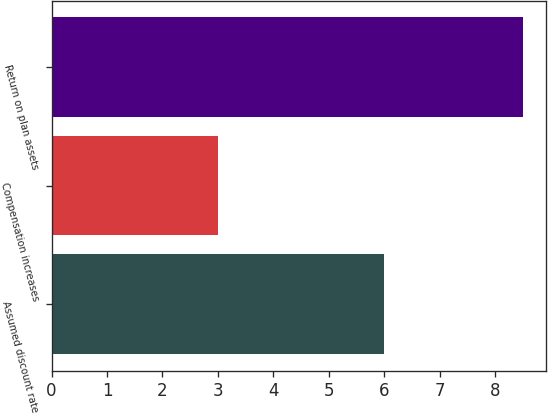<chart> <loc_0><loc_0><loc_500><loc_500><bar_chart><fcel>Assumed discount rate<fcel>Compensation increases<fcel>Return on plan assets<nl><fcel>6<fcel>3<fcel>8.5<nl></chart> 